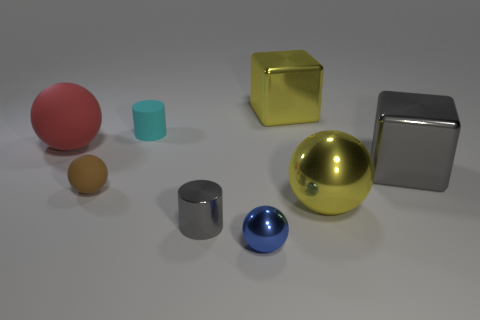There is a gray thing behind the small brown sphere; what shape is it?
Provide a short and direct response. Cube. There is a metallic cube in front of the big sphere left of the large yellow block; how many big shiny blocks are behind it?
Provide a short and direct response. 1. There is a cyan matte object; is its size the same as the sphere that is in front of the large yellow sphere?
Give a very brief answer. Yes. There is a gray metal object that is behind the gray metallic object in front of the gray shiny block; how big is it?
Offer a very short reply. Large. How many things are the same material as the red sphere?
Make the answer very short. 2. Is there a large gray matte cylinder?
Provide a short and direct response. No. What size is the metallic sphere that is behind the tiny metal sphere?
Provide a short and direct response. Large. How many big metal things are the same color as the shiny cylinder?
Ensure brevity in your answer.  1. How many balls are either red objects or large things?
Keep it short and to the point. 2. There is a metal object that is behind the large yellow metallic ball and in front of the large red thing; what shape is it?
Ensure brevity in your answer.  Cube. 